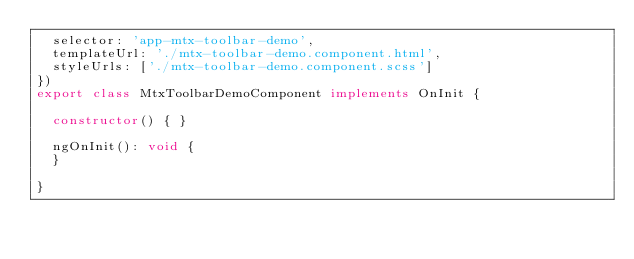Convert code to text. <code><loc_0><loc_0><loc_500><loc_500><_TypeScript_>  selector: 'app-mtx-toolbar-demo',
  templateUrl: './mtx-toolbar-demo.component.html',
  styleUrls: ['./mtx-toolbar-demo.component.scss']
})
export class MtxToolbarDemoComponent implements OnInit {

  constructor() { }

  ngOnInit(): void {
  }

}
</code> 